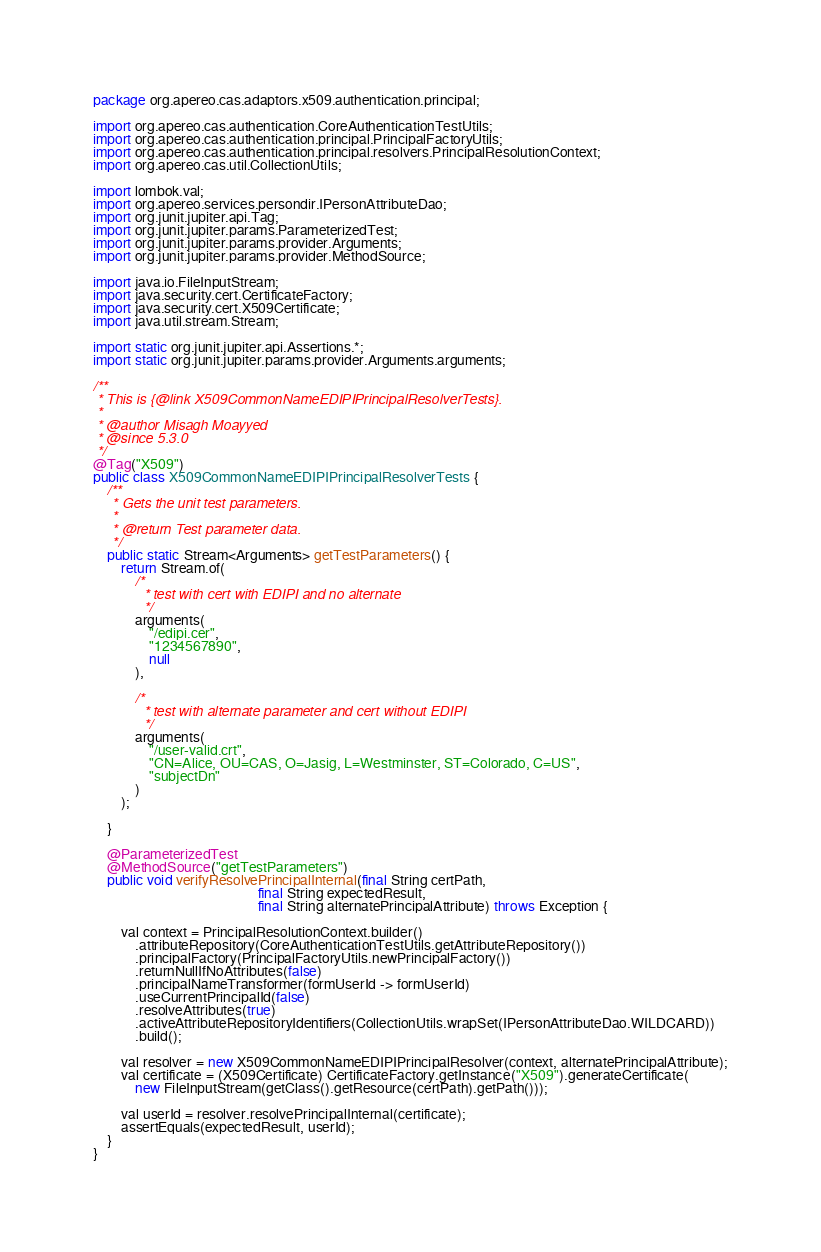Convert code to text. <code><loc_0><loc_0><loc_500><loc_500><_Java_>package org.apereo.cas.adaptors.x509.authentication.principal;

import org.apereo.cas.authentication.CoreAuthenticationTestUtils;
import org.apereo.cas.authentication.principal.PrincipalFactoryUtils;
import org.apereo.cas.authentication.principal.resolvers.PrincipalResolutionContext;
import org.apereo.cas.util.CollectionUtils;

import lombok.val;
import org.apereo.services.persondir.IPersonAttributeDao;
import org.junit.jupiter.api.Tag;
import org.junit.jupiter.params.ParameterizedTest;
import org.junit.jupiter.params.provider.Arguments;
import org.junit.jupiter.params.provider.MethodSource;

import java.io.FileInputStream;
import java.security.cert.CertificateFactory;
import java.security.cert.X509Certificate;
import java.util.stream.Stream;

import static org.junit.jupiter.api.Assertions.*;
import static org.junit.jupiter.params.provider.Arguments.arguments;

/**
 * This is {@link X509CommonNameEDIPIPrincipalResolverTests}.
 *
 * @author Misagh Moayyed
 * @since 5.3.0
 */
@Tag("X509")
public class X509CommonNameEDIPIPrincipalResolverTests {
    /**
     * Gets the unit test parameters.
     *
     * @return Test parameter data.
     */
    public static Stream<Arguments> getTestParameters() {
        return Stream.of(
            /*
             * test with cert with EDIPI and no alternate
             */
            arguments(
                "/edipi.cer",
                "1234567890",
                null
            ),

            /*
             * test with alternate parameter and cert without EDIPI
             */
            arguments(
                "/user-valid.crt",
                "CN=Alice, OU=CAS, O=Jasig, L=Westminster, ST=Colorado, C=US",
                "subjectDn"
            )
        );

    }

    @ParameterizedTest
    @MethodSource("getTestParameters")
    public void verifyResolvePrincipalInternal(final String certPath,
                                               final String expectedResult,
                                               final String alternatePrincipalAttribute) throws Exception {

        val context = PrincipalResolutionContext.builder()
            .attributeRepository(CoreAuthenticationTestUtils.getAttributeRepository())
            .principalFactory(PrincipalFactoryUtils.newPrincipalFactory())
            .returnNullIfNoAttributes(false)
            .principalNameTransformer(formUserId -> formUserId)
            .useCurrentPrincipalId(false)
            .resolveAttributes(true)
            .activeAttributeRepositoryIdentifiers(CollectionUtils.wrapSet(IPersonAttributeDao.WILDCARD))
            .build();

        val resolver = new X509CommonNameEDIPIPrincipalResolver(context, alternatePrincipalAttribute);
        val certificate = (X509Certificate) CertificateFactory.getInstance("X509").generateCertificate(
            new FileInputStream(getClass().getResource(certPath).getPath()));

        val userId = resolver.resolvePrincipalInternal(certificate);
        assertEquals(expectedResult, userId);
    }
}
</code> 